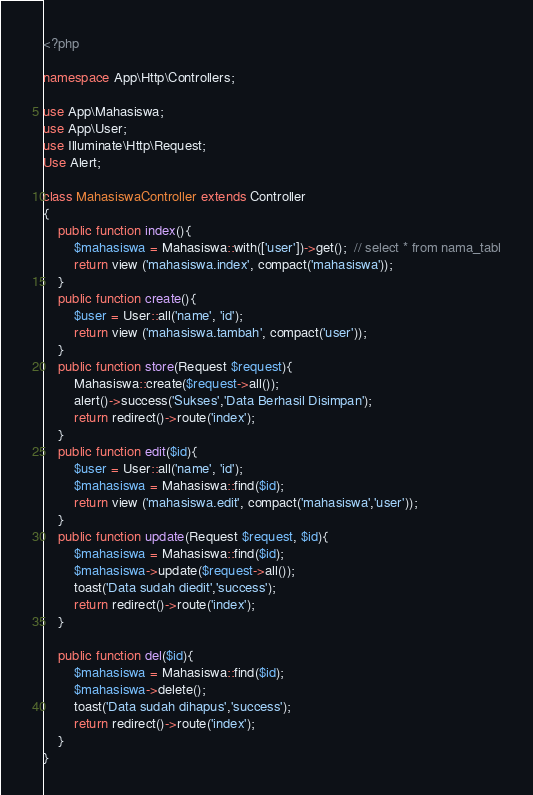Convert code to text. <code><loc_0><loc_0><loc_500><loc_500><_PHP_><?php

namespace App\Http\Controllers;

use App\Mahasiswa;
use App\User;
use Illuminate\Http\Request;
Use Alert;

class MahasiswaController extends Controller
{
    public function index(){
        $mahasiswa = Mahasiswa::with(['user'])->get();  // select * from nama_tabl
        return view ('mahasiswa.index', compact('mahasiswa'));
    }
    public function create(){
        $user = User::all('name', 'id');
        return view ('mahasiswa.tambah', compact('user'));
    }
    public function store(Request $request){
        Mahasiswa::create($request->all());
        alert()->success('Sukses','Data Berhasil Disimpan');
        return redirect()->route('index');
    }
    public function edit($id){
        $user = User::all('name', 'id');
        $mahasiswa = Mahasiswa::find($id);
        return view ('mahasiswa.edit', compact('mahasiswa','user'));
    }
    public function update(Request $request, $id){
        $mahasiswa = Mahasiswa::find($id);
        $mahasiswa->update($request->all());
        toast('Data sudah diedit','success');
        return redirect()->route('index');
    }

    public function del($id){
        $mahasiswa = Mahasiswa::find($id);
        $mahasiswa->delete();
        toast('Data sudah dihapus','success');
        return redirect()->route('index');
    }
}</code> 